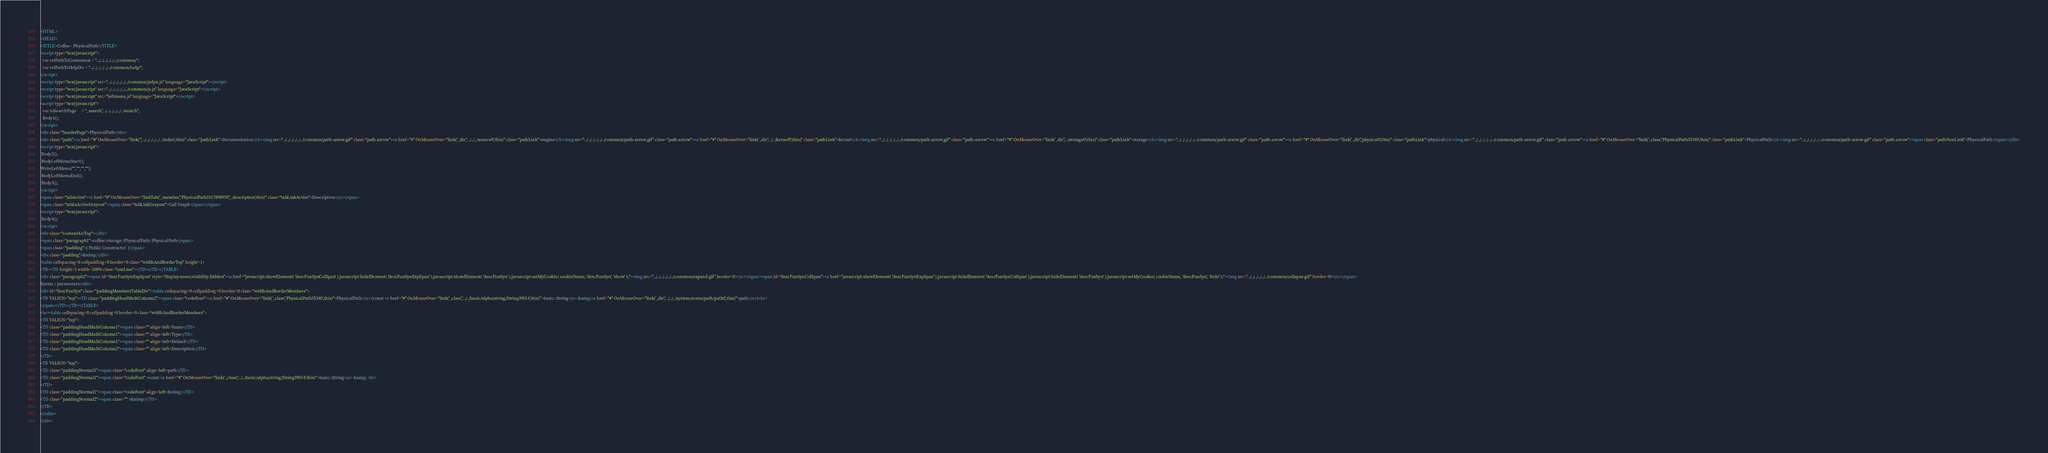<code> <loc_0><loc_0><loc_500><loc_500><_HTML_><HTML>
<HEAD>
<TITLE>Coffee - PhysicalPath</TITLE>
<script type="text/javascript">
  var relPathToCommmon = "../../../../../../common/";
  var relPathToHelpDir = "../../../../../../common/help/";
</script>
<script type="text/javascript" src="../../../../../../common/jsdyn.js" language="JavaScript"></script>
<script type="text/javascript" src="../../../../../../common/js.js" language="JavaScript"></script>
<script type="text/javascript" src="leftmenu.js" language="JavaScript"></script>
<script type="text/javascript">
  var toSearchPage     = "_search','../../../../../../search";
  Body1();
</script>
<div class="headerPage">PhysicalPath</div>
<div class="path"><a href="#" OnMouseOver="link('','../../../../../../index',this)" class="pathLink">Documentation</A><img src="../../../../../../common/path-arrow.gif" class="path-arrow"><a href="#" OnMouseOver="link('_dir','../../../source0',this)" class="pathLink">engine</A><img src="../../../../../../common/path-arrow.gif" class="path-arrow"><a href="#" OnMouseOver="link('_dir','../../kernel0',this)" class="pathLink">kernel</A><img src="../../../../../../common/path-arrow.gif" class="path-arrow"><a href="#" OnMouseOver="link('_dir','../storage0',this)" class="pathLink">storage</A><img src="../../../../../../common/path-arrow.gif" class="path-arrow"><a href="#" OnMouseOver="link('_dir','physical0',this)" class="pathLink">physical</A><img src="../../../../../../common/path-arrow.gif" class="path-arrow"><a href="#" OnMouseOver="link('_class','PhysicalPath35340',this)" class="pathLink">PhysicalPath</A><img src="../../../../../../common/path-arrow.gif" class="path-arrow"><span class="pathNonLink">PhysicalPath</span></div>
<script type="text/javascript">
 Body2();
 BodyLeftMenuStart();
WriteLeftMenu("","","","");
 BodyLeftMenuEnd();
 Body3();
</script>
<span class="tabActive"><a href="#" OnMouseOver="linkTab('_member','PhysicalPath1017898959','_description',this)" class="tabLinkActive">Description</a></span>
<span class="tabInActiveGrayout"><span class="tabLinkGrayout">Call Graph</span></span>
<script type="text/javascript">
 Body4();
</script>
<div class="contentAirTop"></div>
<span class="paragraph1">coffee::storage::PhysicalPath::PhysicalPath</span>
<span class="padding">( Public Constructor  )</span>
<div class="padding">&nbsp;</div>
<table cellspacing=0 cellpadding=0 border=0 class="widthAndBorderTop" height=1>
<TR><TD height=1 width=100% class="oneLine"></TD></TR></TABLE>
<div class="paragraph2"><span id="descFunSynExpSpan" style="display:none;visibility:hidden"><a href="javascript:showElement( 'descFunSynColSpan' );javascript:hideElement( 'descFunSynExpSpan' );javascript:showElement( 'descFunSyn' );javascript:setMyCookie( cookieName, 'descFunSyn', 'show' );"><img src="../../../../../../common/expand.gif" border=0></a></span><span id="descFunSynColSpan"><a href="javascript:showElement( 'descFunSynExpSpan' );javascript:hideElement( 'descFunSynColSpan' );javascript:hideElement( 'descFunSyn' );javascript:setMyCookie( cookieName, 'descFunSyn', 'hide' );"><img src="../../../../../../common/collapse.gif" border=0></a></span>
Syntax / parameters</div>
<div id="descFunSyn" class="paddingMembersTableDiv"><table cellspacing=0 cellpadding=0 border=0 class="widthAndBorderMembers">
<TR VALIGN="top"><TD class="paddingHeadMultiColumn2"><span class="codeFont"><a href="#" OnMouseOver="link('_class','PhysicalPath35340',this)">PhysicalPath</a> (const <a href="#" OnMouseOver="link('_class','../../basic/alpha/string/String39014',this)">basic::String</a> &amp;<a href="#" OnMouseOver="link('_dir','../../../system/scene/path/path0',this)">path</a>)<br>
</span></TD></TR></TABLE>
<br><table cellspacing=0 cellpadding=0 border=0 class="widthAndBorderMembers">
<TR VALIGN="top">
<TD class="paddingHeadMultiColumn1"><span class="" align=left>Name</TD>
<TD class="paddingHeadMultiColumn1"><span class="" align=left>Type</TD>
<TD class="paddingHeadMultiColumn1"><span class="" align=left>Default</TD>
<TD class="paddingHeadMultiColumn2"><span class="" align=left>Description</TD>
</TR>
<TR VALIGN="top">
<TD class="paddingNormal1"><span class="codeFont" align=left>path</TD>
<TD class="paddingNormal1"><span class="codeFont" >const <a href="#" OnMouseOver="link('_class','../../basic/alpha/string/String39014',this)">basic::String</a> &amp; <br>
</TD>
<TD class="paddingNormal1"><span class="codeFont" align=left>&nbsp;</TD>
<TD class="paddingNormal2"><span class="" >&nbsp;</TD>
</TR>
</table>
</div></code> 